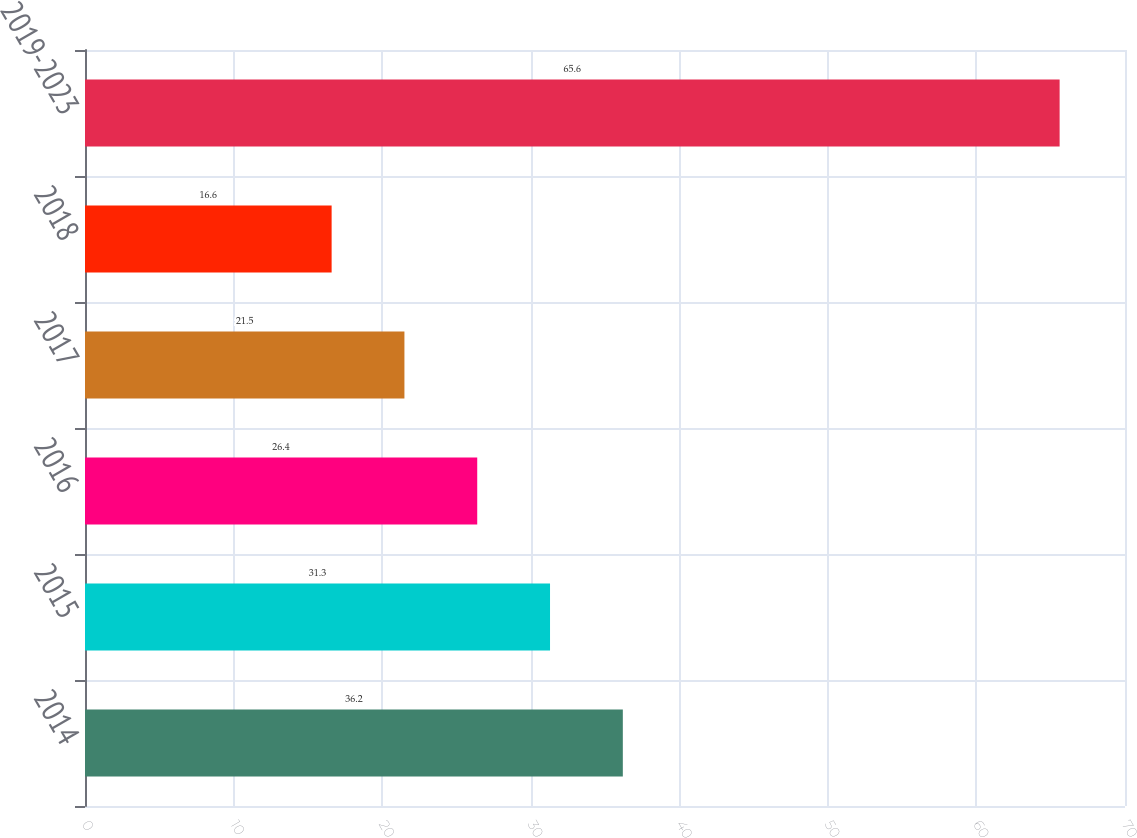Convert chart to OTSL. <chart><loc_0><loc_0><loc_500><loc_500><bar_chart><fcel>2014<fcel>2015<fcel>2016<fcel>2017<fcel>2018<fcel>2019-2023<nl><fcel>36.2<fcel>31.3<fcel>26.4<fcel>21.5<fcel>16.6<fcel>65.6<nl></chart> 